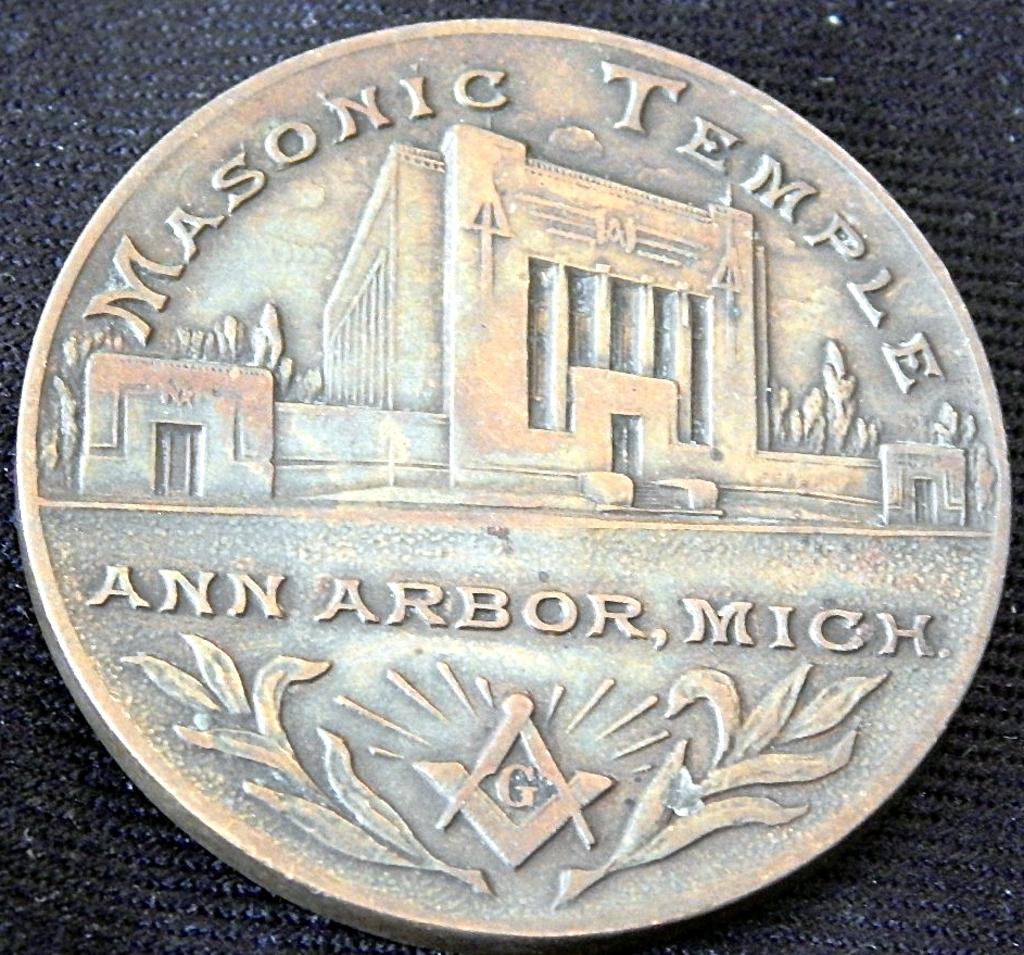<image>
Create a compact narrative representing the image presented. the front of a coin for the masonic temple in ann arbor michigan 